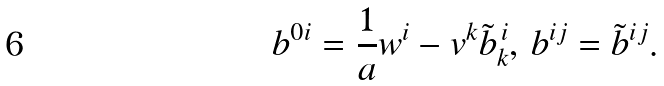Convert formula to latex. <formula><loc_0><loc_0><loc_500><loc_500>b ^ { 0 i } = \frac { 1 } { a } w ^ { i } - v ^ { k } { \tilde { b } } _ { k } ^ { \, i } , \, b ^ { i j } = { \tilde { b } } ^ { i j } .</formula> 